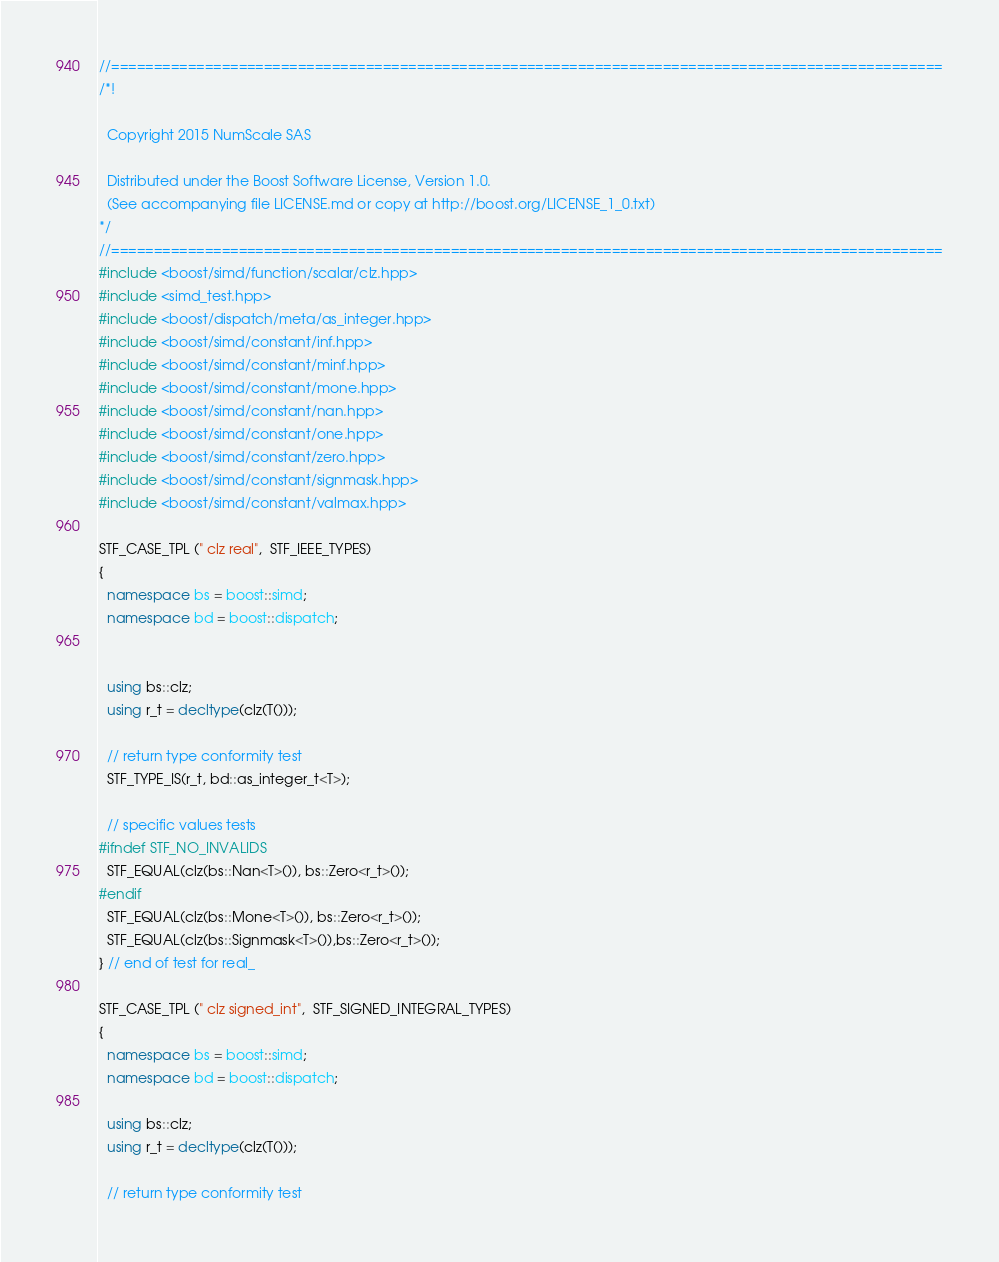<code> <loc_0><loc_0><loc_500><loc_500><_C++_>//==================================================================================================
/*!

  Copyright 2015 NumScale SAS

  Distributed under the Boost Software License, Version 1.0.
  (See accompanying file LICENSE.md or copy at http://boost.org/LICENSE_1_0.txt)
*/
//==================================================================================================
#include <boost/simd/function/scalar/clz.hpp>
#include <simd_test.hpp>
#include <boost/dispatch/meta/as_integer.hpp>
#include <boost/simd/constant/inf.hpp>
#include <boost/simd/constant/minf.hpp>
#include <boost/simd/constant/mone.hpp>
#include <boost/simd/constant/nan.hpp>
#include <boost/simd/constant/one.hpp>
#include <boost/simd/constant/zero.hpp>
#include <boost/simd/constant/signmask.hpp>
#include <boost/simd/constant/valmax.hpp>

STF_CASE_TPL (" clz real",  STF_IEEE_TYPES)
{
  namespace bs = boost::simd;
  namespace bd = boost::dispatch;


  using bs::clz;
  using r_t = decltype(clz(T()));

  // return type conformity test
  STF_TYPE_IS(r_t, bd::as_integer_t<T>);

  // specific values tests
#ifndef STF_NO_INVALIDS
  STF_EQUAL(clz(bs::Nan<T>()), bs::Zero<r_t>());
#endif
  STF_EQUAL(clz(bs::Mone<T>()), bs::Zero<r_t>());
  STF_EQUAL(clz(bs::Signmask<T>()),bs::Zero<r_t>());
} // end of test for real_

STF_CASE_TPL (" clz signed_int",  STF_SIGNED_INTEGRAL_TYPES)
{
  namespace bs = boost::simd;
  namespace bd = boost::dispatch;

  using bs::clz;
  using r_t = decltype(clz(T()));

  // return type conformity test</code> 